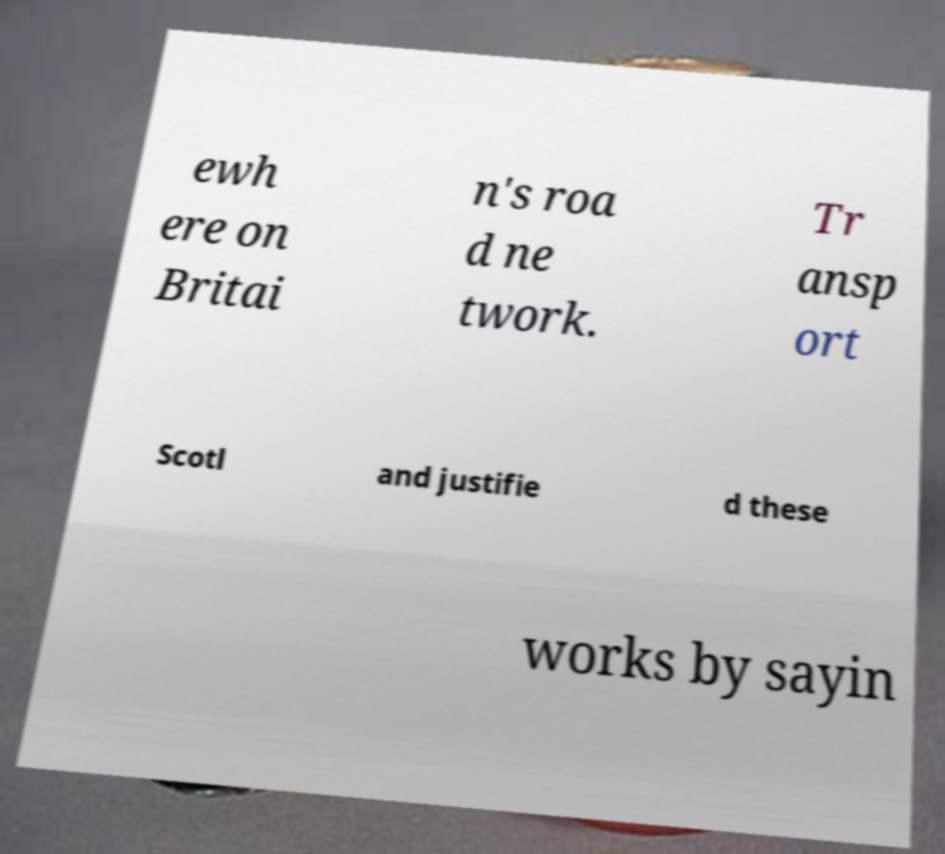There's text embedded in this image that I need extracted. Can you transcribe it verbatim? ewh ere on Britai n's roa d ne twork. Tr ansp ort Scotl and justifie d these works by sayin 